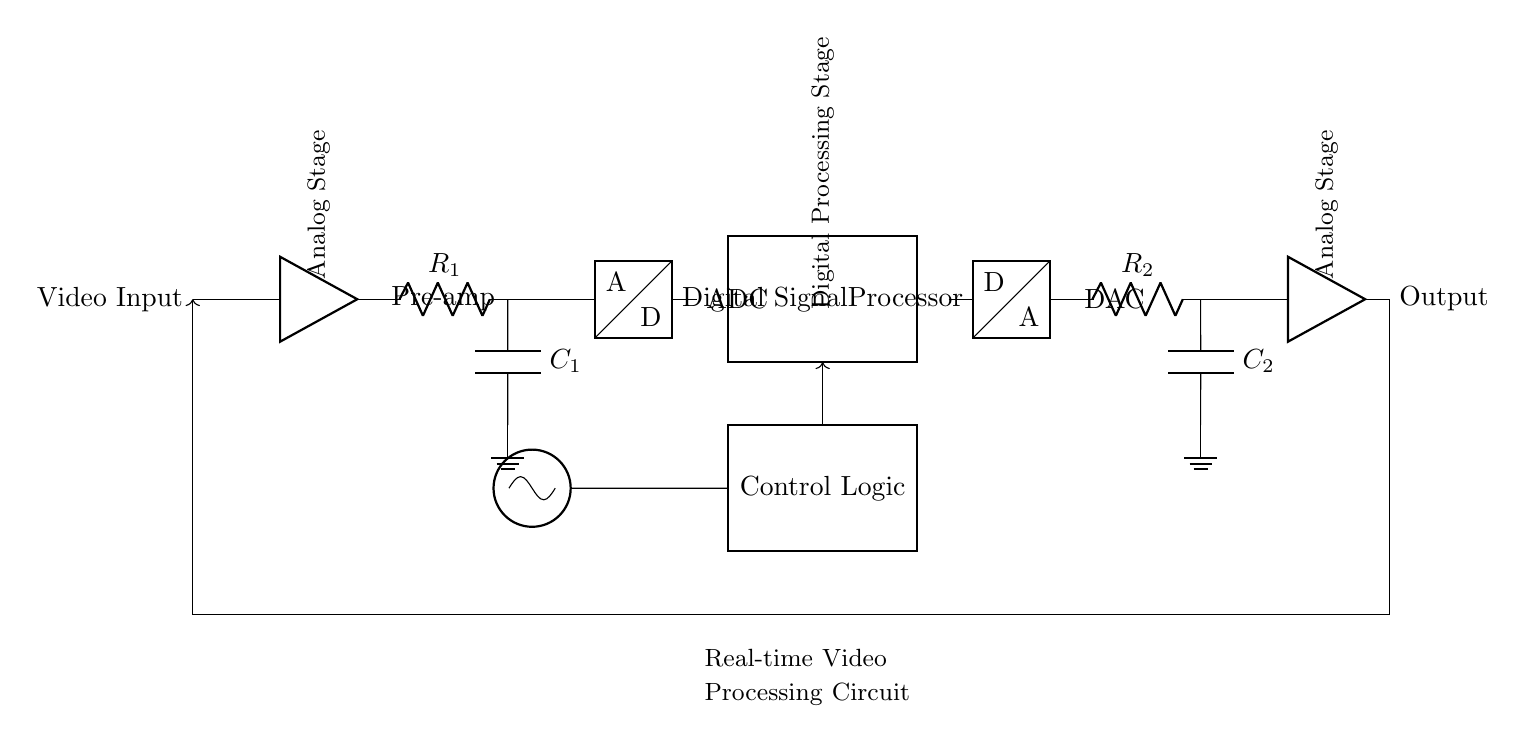What is the first component in the circuit? The first component visible in the circuit diagram is the "Video Input" which initiates the flow of the signal.
Answer: Video Input What type of filter is used in the circuit? A low-pass filter is utilized, as indicated by the resistor and capacitor connected in series, allowing lower frequency signals to pass while attenuating higher frequencies.
Answer: Low-pass filter How many amplifiers are present in the circuit? There are two amplifiers in the circuit: one at the Input stage (Pre-amp) and another at the Output stage.
Answer: Two What is the primary function of the Digital Signal Processor? The Digital Signal Processor is responsible for manipulating and processing the video signal digitally after conversion by the ADC, crucial for enhancing video quality or applying effects in real-time.
Answer: Video processing Which component converts the analog signal back to digital? The DAC (Digital-to-Analog Converter) is the component that converts the processed digital signal back into an analog format for output.
Answer: DAC What type of feedback is employed in this circuit? The circuit uses a feedback loop where the output is fed back to the input, ensuring the system can process and adjust the signal continuously.
Answer: Feedback loop What role does the Clock play in this circuit? The Clock generates timing signals that synchronize the operations of the ADC and DSP, ensuring proper data sampling and processing in real-time video applications.
Answer: Synchronization 